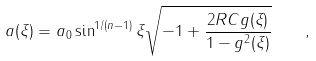Convert formula to latex. <formula><loc_0><loc_0><loc_500><loc_500>a ( \xi ) = a _ { 0 } \sin ^ { 1 / ( n - 1 ) } \xi \sqrt { - 1 + \frac { 2 R C g ( \xi ) } { 1 - g ^ { 2 } ( \xi ) } } \quad ,</formula> 